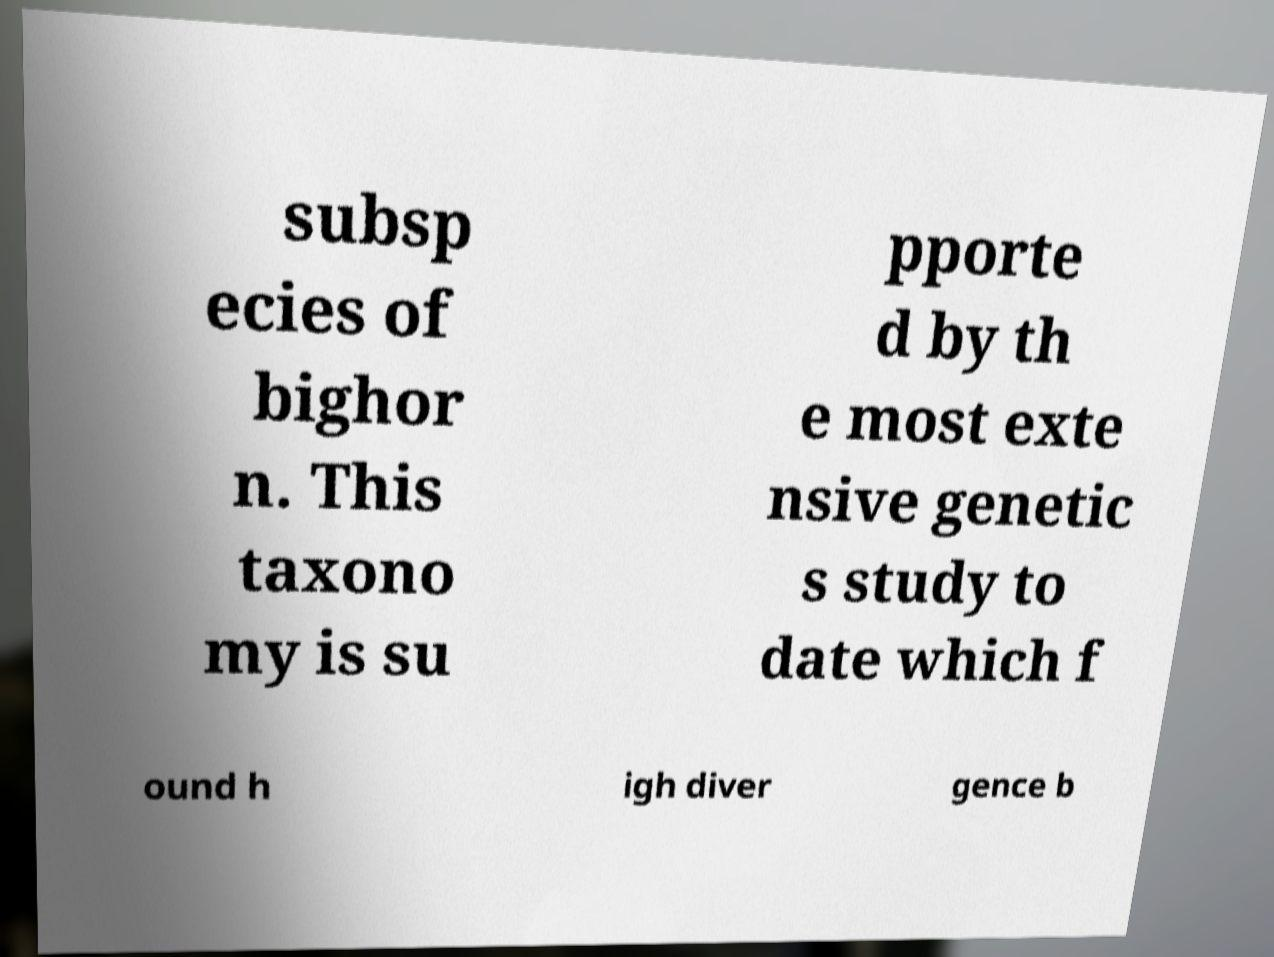Can you accurately transcribe the text from the provided image for me? subsp ecies of bighor n. This taxono my is su pporte d by th e most exte nsive genetic s study to date which f ound h igh diver gence b 